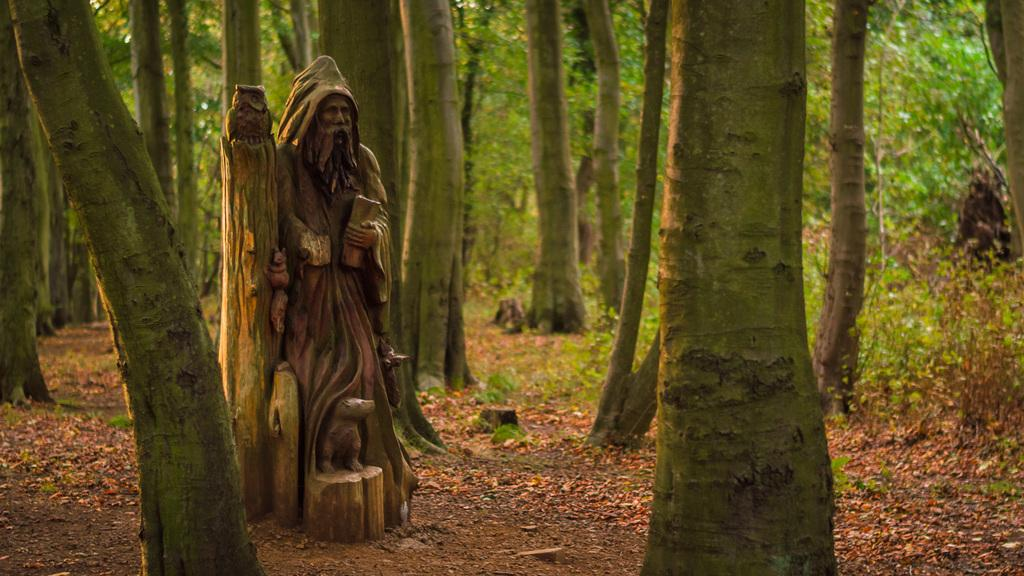What type of statue is depicted in the image? There is a statue of a person holding something in the image. Are there any other statues in the image besides the one of a person? Yes, there are statues of animals in the image. Can you describe the statue of a bird in the image? There is a statue of a bird in the image. What type of vegetation is present in the image? There are trees in the image. What type of weather is depicted in the image? The image does not depict any weather conditions; it only shows statues and trees. How many turkeys are present in the image? There are no turkeys present in the image. 